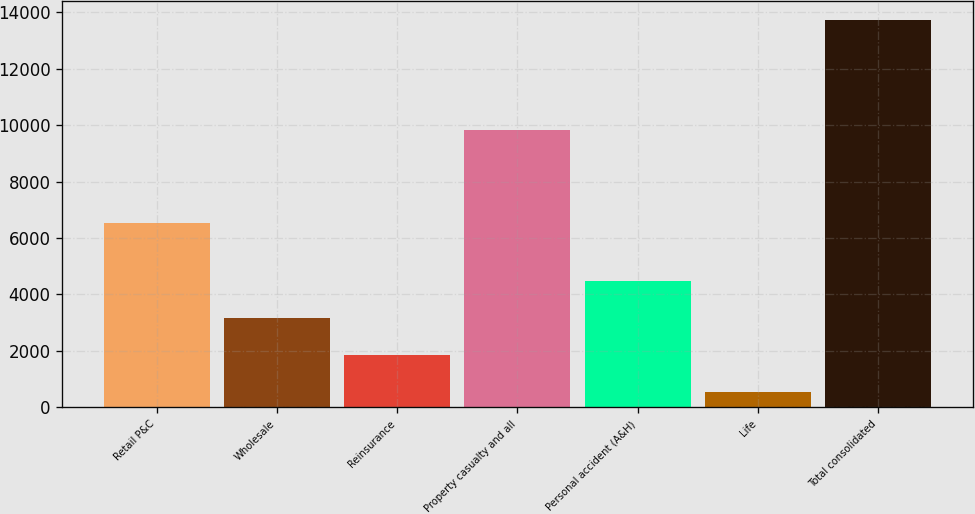Convert chart. <chart><loc_0><loc_0><loc_500><loc_500><bar_chart><fcel>Retail P&C<fcel>Wholesale<fcel>Reinsurance<fcel>Property casualty and all<fcel>Personal accident (A&H)<fcel>Life<fcel>Total consolidated<nl><fcel>6533<fcel>3175.2<fcel>1858.6<fcel>9820<fcel>4491.8<fcel>542<fcel>13708<nl></chart> 